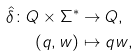Convert formula to latex. <formula><loc_0><loc_0><loc_500><loc_500>\hat { \delta } \colon Q \times \Sigma ^ { * } & \rightarrow Q , \\ ( q , w ) & \mapsto q w ,</formula> 